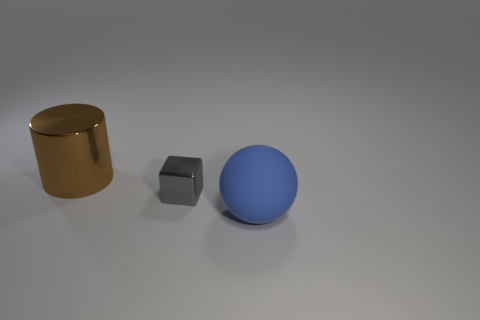Add 1 tiny gray cubes. How many objects exist? 4 Subtract all balls. How many objects are left? 2 Subtract all big yellow metallic cubes. Subtract all big brown shiny cylinders. How many objects are left? 2 Add 3 big rubber balls. How many big rubber balls are left? 4 Add 1 large matte objects. How many large matte objects exist? 2 Subtract 0 purple spheres. How many objects are left? 3 